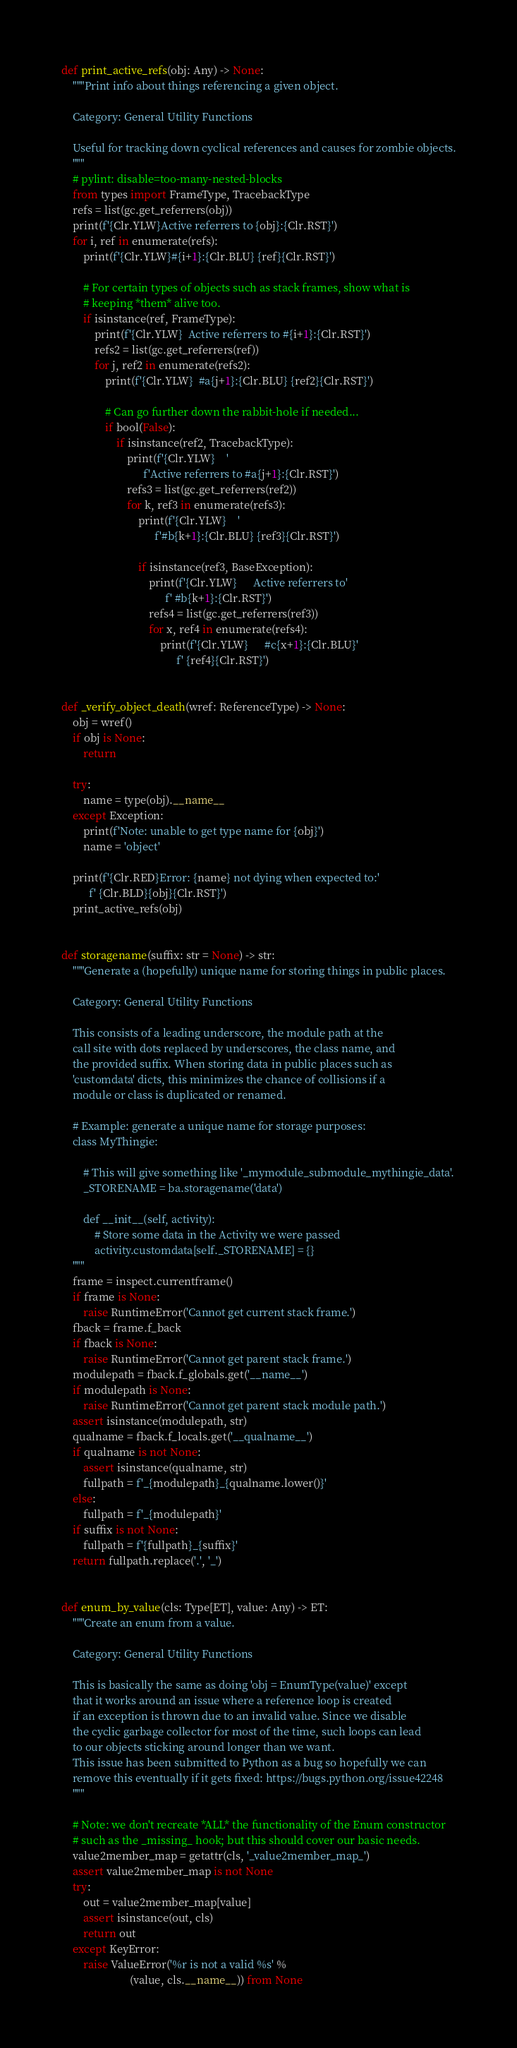<code> <loc_0><loc_0><loc_500><loc_500><_Python_>def print_active_refs(obj: Any) -> None:
    """Print info about things referencing a given object.

    Category: General Utility Functions

    Useful for tracking down cyclical references and causes for zombie objects.
    """
    # pylint: disable=too-many-nested-blocks
    from types import FrameType, TracebackType
    refs = list(gc.get_referrers(obj))
    print(f'{Clr.YLW}Active referrers to {obj}:{Clr.RST}')
    for i, ref in enumerate(refs):
        print(f'{Clr.YLW}#{i+1}:{Clr.BLU} {ref}{Clr.RST}')

        # For certain types of objects such as stack frames, show what is
        # keeping *them* alive too.
        if isinstance(ref, FrameType):
            print(f'{Clr.YLW}  Active referrers to #{i+1}:{Clr.RST}')
            refs2 = list(gc.get_referrers(ref))
            for j, ref2 in enumerate(refs2):
                print(f'{Clr.YLW}  #a{j+1}:{Clr.BLU} {ref2}{Clr.RST}')

                # Can go further down the rabbit-hole if needed...
                if bool(False):
                    if isinstance(ref2, TracebackType):
                        print(f'{Clr.YLW}    '
                              f'Active referrers to #a{j+1}:{Clr.RST}')
                        refs3 = list(gc.get_referrers(ref2))
                        for k, ref3 in enumerate(refs3):
                            print(f'{Clr.YLW}    '
                                  f'#b{k+1}:{Clr.BLU} {ref3}{Clr.RST}')

                            if isinstance(ref3, BaseException):
                                print(f'{Clr.YLW}      Active referrers to'
                                      f' #b{k+1}:{Clr.RST}')
                                refs4 = list(gc.get_referrers(ref3))
                                for x, ref4 in enumerate(refs4):
                                    print(f'{Clr.YLW}      #c{x+1}:{Clr.BLU}'
                                          f' {ref4}{Clr.RST}')


def _verify_object_death(wref: ReferenceType) -> None:
    obj = wref()
    if obj is None:
        return

    try:
        name = type(obj).__name__
    except Exception:
        print(f'Note: unable to get type name for {obj}')
        name = 'object'

    print(f'{Clr.RED}Error: {name} not dying when expected to:'
          f' {Clr.BLD}{obj}{Clr.RST}')
    print_active_refs(obj)


def storagename(suffix: str = None) -> str:
    """Generate a (hopefully) unique name for storing things in public places.

    Category: General Utility Functions

    This consists of a leading underscore, the module path at the
    call site with dots replaced by underscores, the class name, and
    the provided suffix. When storing data in public places such as
    'customdata' dicts, this minimizes the chance of collisions if a
    module or class is duplicated or renamed.

    # Example: generate a unique name for storage purposes:
    class MyThingie:

        # This will give something like '_mymodule_submodule_mythingie_data'.
        _STORENAME = ba.storagename('data')

        def __init__(self, activity):
            # Store some data in the Activity we were passed
            activity.customdata[self._STORENAME] = {}
    """
    frame = inspect.currentframe()
    if frame is None:
        raise RuntimeError('Cannot get current stack frame.')
    fback = frame.f_back
    if fback is None:
        raise RuntimeError('Cannot get parent stack frame.')
    modulepath = fback.f_globals.get('__name__')
    if modulepath is None:
        raise RuntimeError('Cannot get parent stack module path.')
    assert isinstance(modulepath, str)
    qualname = fback.f_locals.get('__qualname__')
    if qualname is not None:
        assert isinstance(qualname, str)
        fullpath = f'_{modulepath}_{qualname.lower()}'
    else:
        fullpath = f'_{modulepath}'
    if suffix is not None:
        fullpath = f'{fullpath}_{suffix}'
    return fullpath.replace('.', '_')


def enum_by_value(cls: Type[ET], value: Any) -> ET:
    """Create an enum from a value.

    Category: General Utility Functions

    This is basically the same as doing 'obj = EnumType(value)' except
    that it works around an issue where a reference loop is created
    if an exception is thrown due to an invalid value. Since we disable
    the cyclic garbage collector for most of the time, such loops can lead
    to our objects sticking around longer than we want.
    This issue has been submitted to Python as a bug so hopefully we can
    remove this eventually if it gets fixed: https://bugs.python.org/issue42248
    """

    # Note: we don't recreate *ALL* the functionality of the Enum constructor
    # such as the _missing_ hook; but this should cover our basic needs.
    value2member_map = getattr(cls, '_value2member_map_')
    assert value2member_map is not None
    try:
        out = value2member_map[value]
        assert isinstance(out, cls)
        return out
    except KeyError:
        raise ValueError('%r is not a valid %s' %
                         (value, cls.__name__)) from None
</code> 